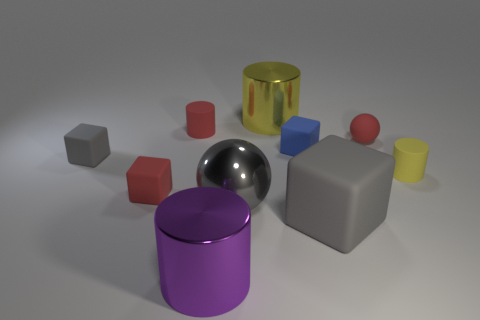Subtract all purple blocks. How many yellow cylinders are left? 2 Subtract all yellow matte cylinders. How many cylinders are left? 3 Subtract all blue blocks. How many blocks are left? 3 Subtract all cyan blocks. Subtract all blue cylinders. How many blocks are left? 4 Subtract all spheres. How many objects are left? 8 Add 4 purple cubes. How many purple cubes exist? 4 Subtract 0 green cylinders. How many objects are left? 10 Subtract all blue matte balls. Subtract all purple metal things. How many objects are left? 9 Add 4 big purple objects. How many big purple objects are left? 5 